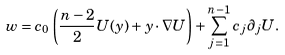<formula> <loc_0><loc_0><loc_500><loc_500>w = c _ { 0 } \left ( \frac { n - 2 } { 2 } U ( y ) + y \cdot \nabla U \right ) + \sum _ { j = 1 } ^ { n - 1 } c _ { j } \partial _ { j } U .</formula> 